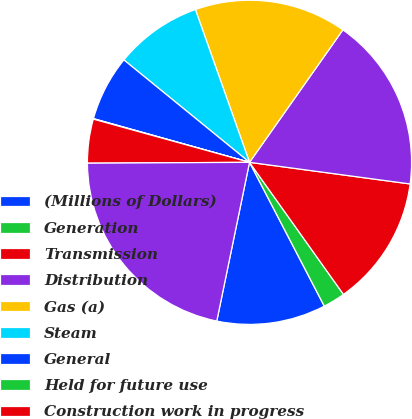Convert chart to OTSL. <chart><loc_0><loc_0><loc_500><loc_500><pie_chart><fcel>(Millions of Dollars)<fcel>Generation<fcel>Transmission<fcel>Distribution<fcel>Gas (a)<fcel>Steam<fcel>General<fcel>Held for future use<fcel>Construction work in progress<fcel>Net Utility Plant<nl><fcel>10.87%<fcel>2.21%<fcel>13.03%<fcel>17.36%<fcel>15.19%<fcel>8.7%<fcel>6.54%<fcel>0.05%<fcel>4.38%<fcel>21.68%<nl></chart> 